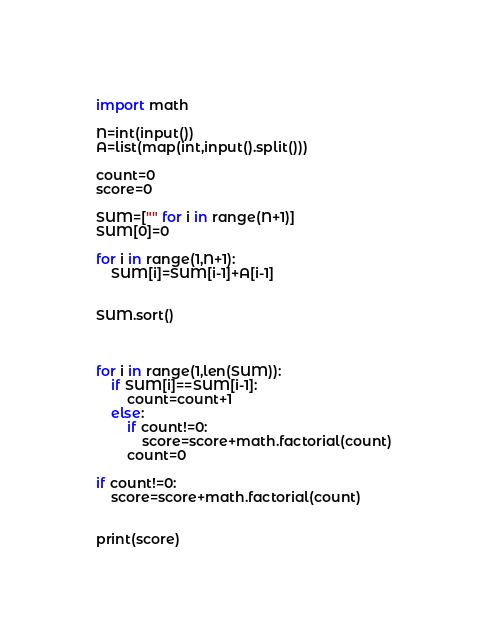<code> <loc_0><loc_0><loc_500><loc_500><_Python_>import math

N=int(input())
A=list(map(int,input().split()))
 
count=0
score=0

SUM=["" for i in range(N+1)]
SUM[0]=0
 
for i in range(1,N+1):
    SUM[i]=SUM[i-1]+A[i-1]

    
SUM.sort()



for i in range(1,len(SUM)):
    if SUM[i]==SUM[i-1]:
        count=count+1
    else:
        if count!=0:
            score=score+math.factorial(count)
        count=0
        
if count!=0:
    score=score+math.factorial(count)

 
print(score)
</code> 